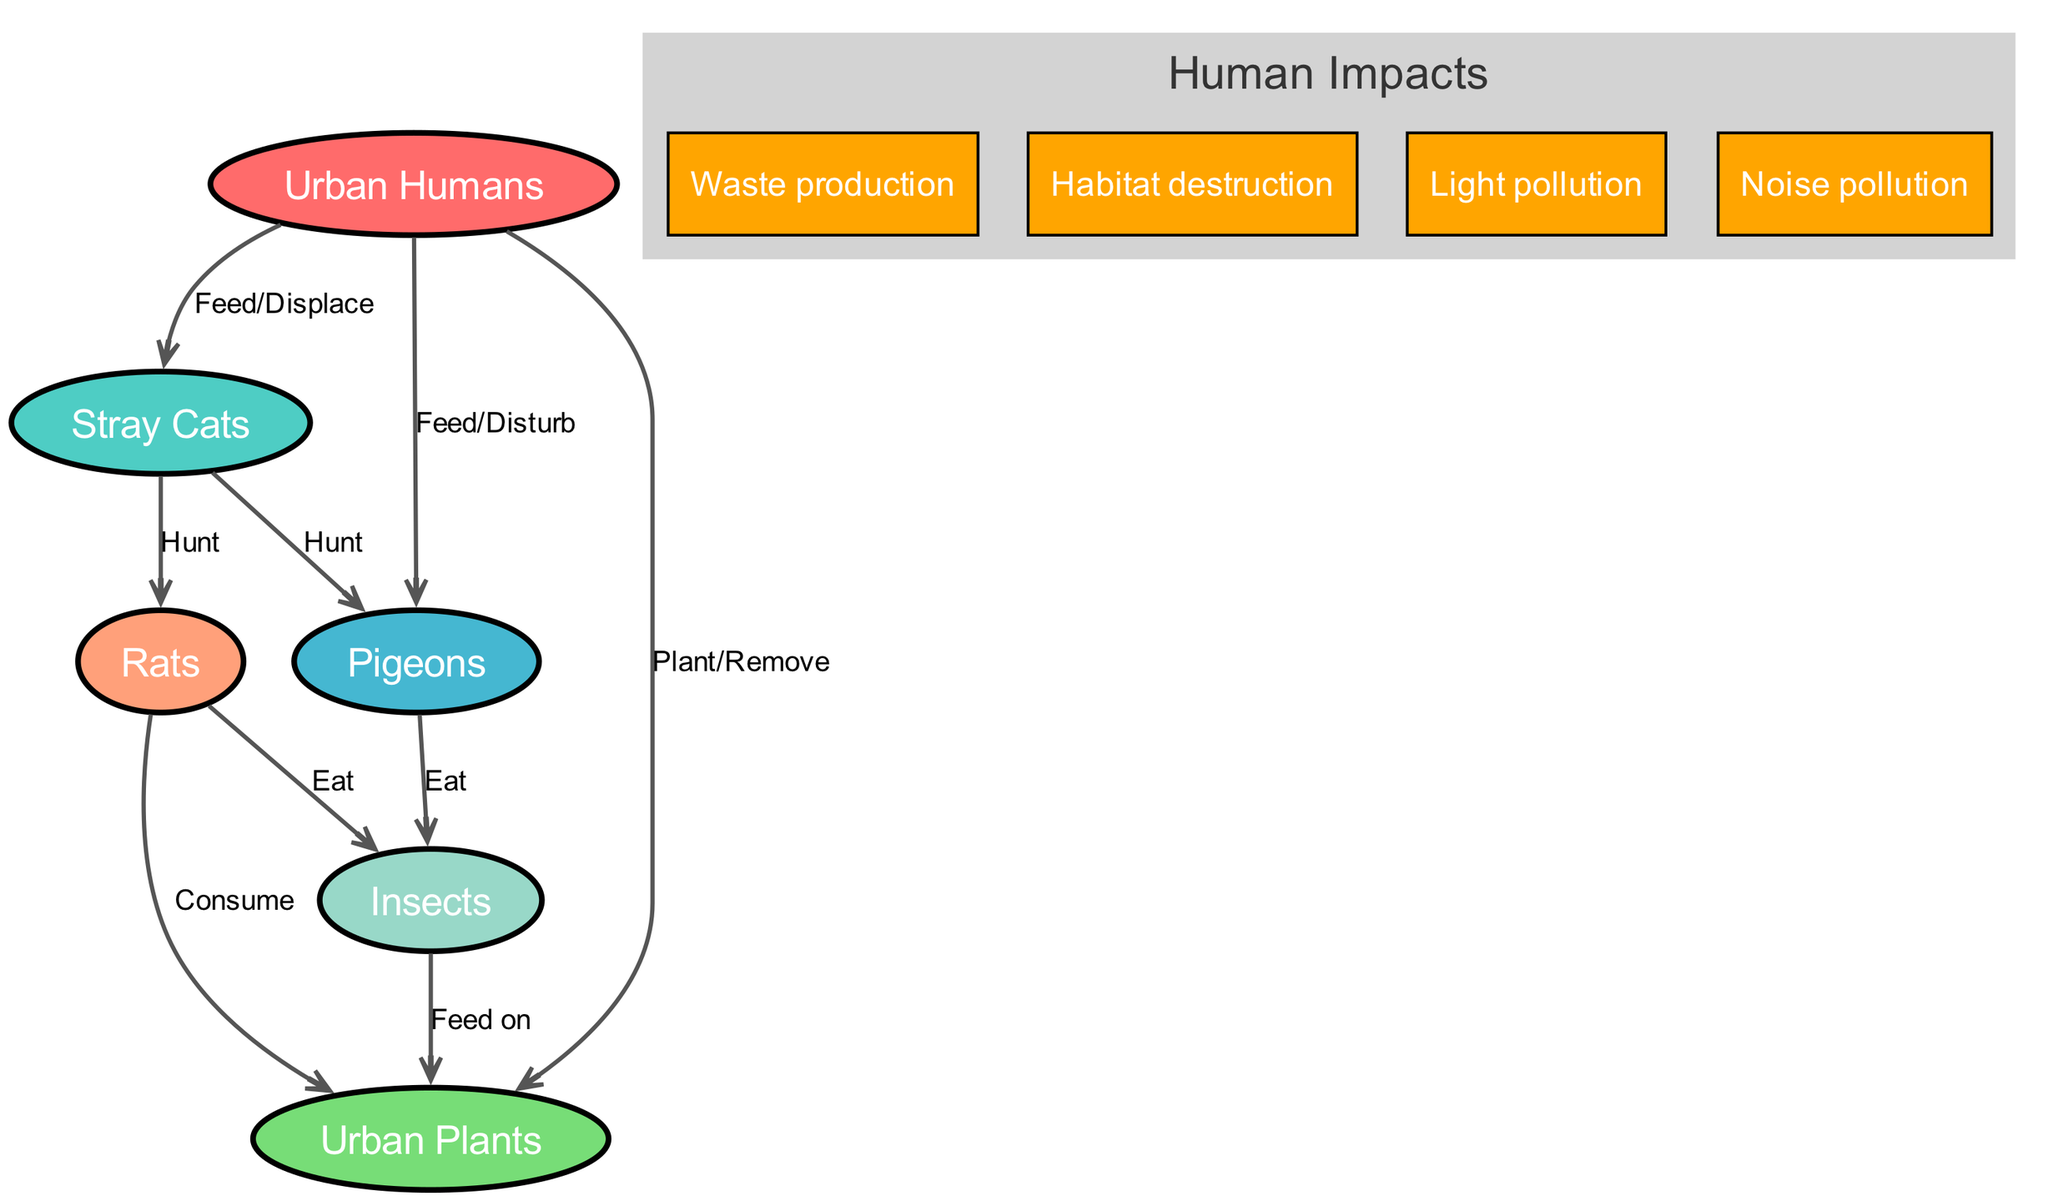What is the total number of organisms in the diagram? The diagram lists six organisms: Urban Humans, Stray Cats, Pigeons, Rats, Insects, and Urban Plants. To find the total, we simply count these items.
Answer: 6 Which organism is hunted by Stray Cats? The diagram indicates two organisms that are hunted by Stray Cats: Pigeons and Rats. However, the question asks for just one, so we can choose either. The edge going from Stray Cats to Pigeons specifies "Hunt".
Answer: Pigeons What is the relationship between Urban Humans and Urban Plants? The diagram shows a directed edge labeled "Plant/Remove" transitioning from Urban Humans to Urban Plants. This indicates that Urban Humans engage in planting or removing Urban Plants.
Answer: Plant/Remove How many impacts of human activities are listed in the diagram? The diagram specifies four distinct impacts of human activities, namely Waste production, Habitat destruction, Light pollution, and Noise pollution. Here, we simply count these separate impacts to arrive at the answer.
Answer: 4 Which organism consumes Urban Plants? The diagram indicates that Rats have a directed edge labeled "Consume" directed towards Urban Plants. Therefore, Rats are identified as the organisms that consume Urban Plants.
Answer: Rats What is the label of the edge from Pigeons to Insects? Observing the diagram, the edge leading from Pigeons to Insects is described with the label "Eat". This shows the dietary relationship between these two organisms.
Answer: Eat What role do Insects play in the food chain of this urban ecosystem? Insects are shown to have a relationship with Urban Plants, where they "Feed on" them, suggesting their role as consumers within the plant community.
Answer: Feed on Which organism do Urban Humans disturb? The diagram indicates a relationship labeled "Feed/Disturb" going from Urban Humans to Pigeons. This shows that Urban Humans have a disturbing impact on Pigeons in the ecosystem.
Answer: Pigeons What is one effect of urbanization highlighted in the diagram? The diagram lists multiple human impacts on local wildlife, including Waste production, Habitat destruction, Light pollution, and Noise pollution. These effects highlight how urban growth can disrupt ecosystems.
Answer: Habitat destruction 